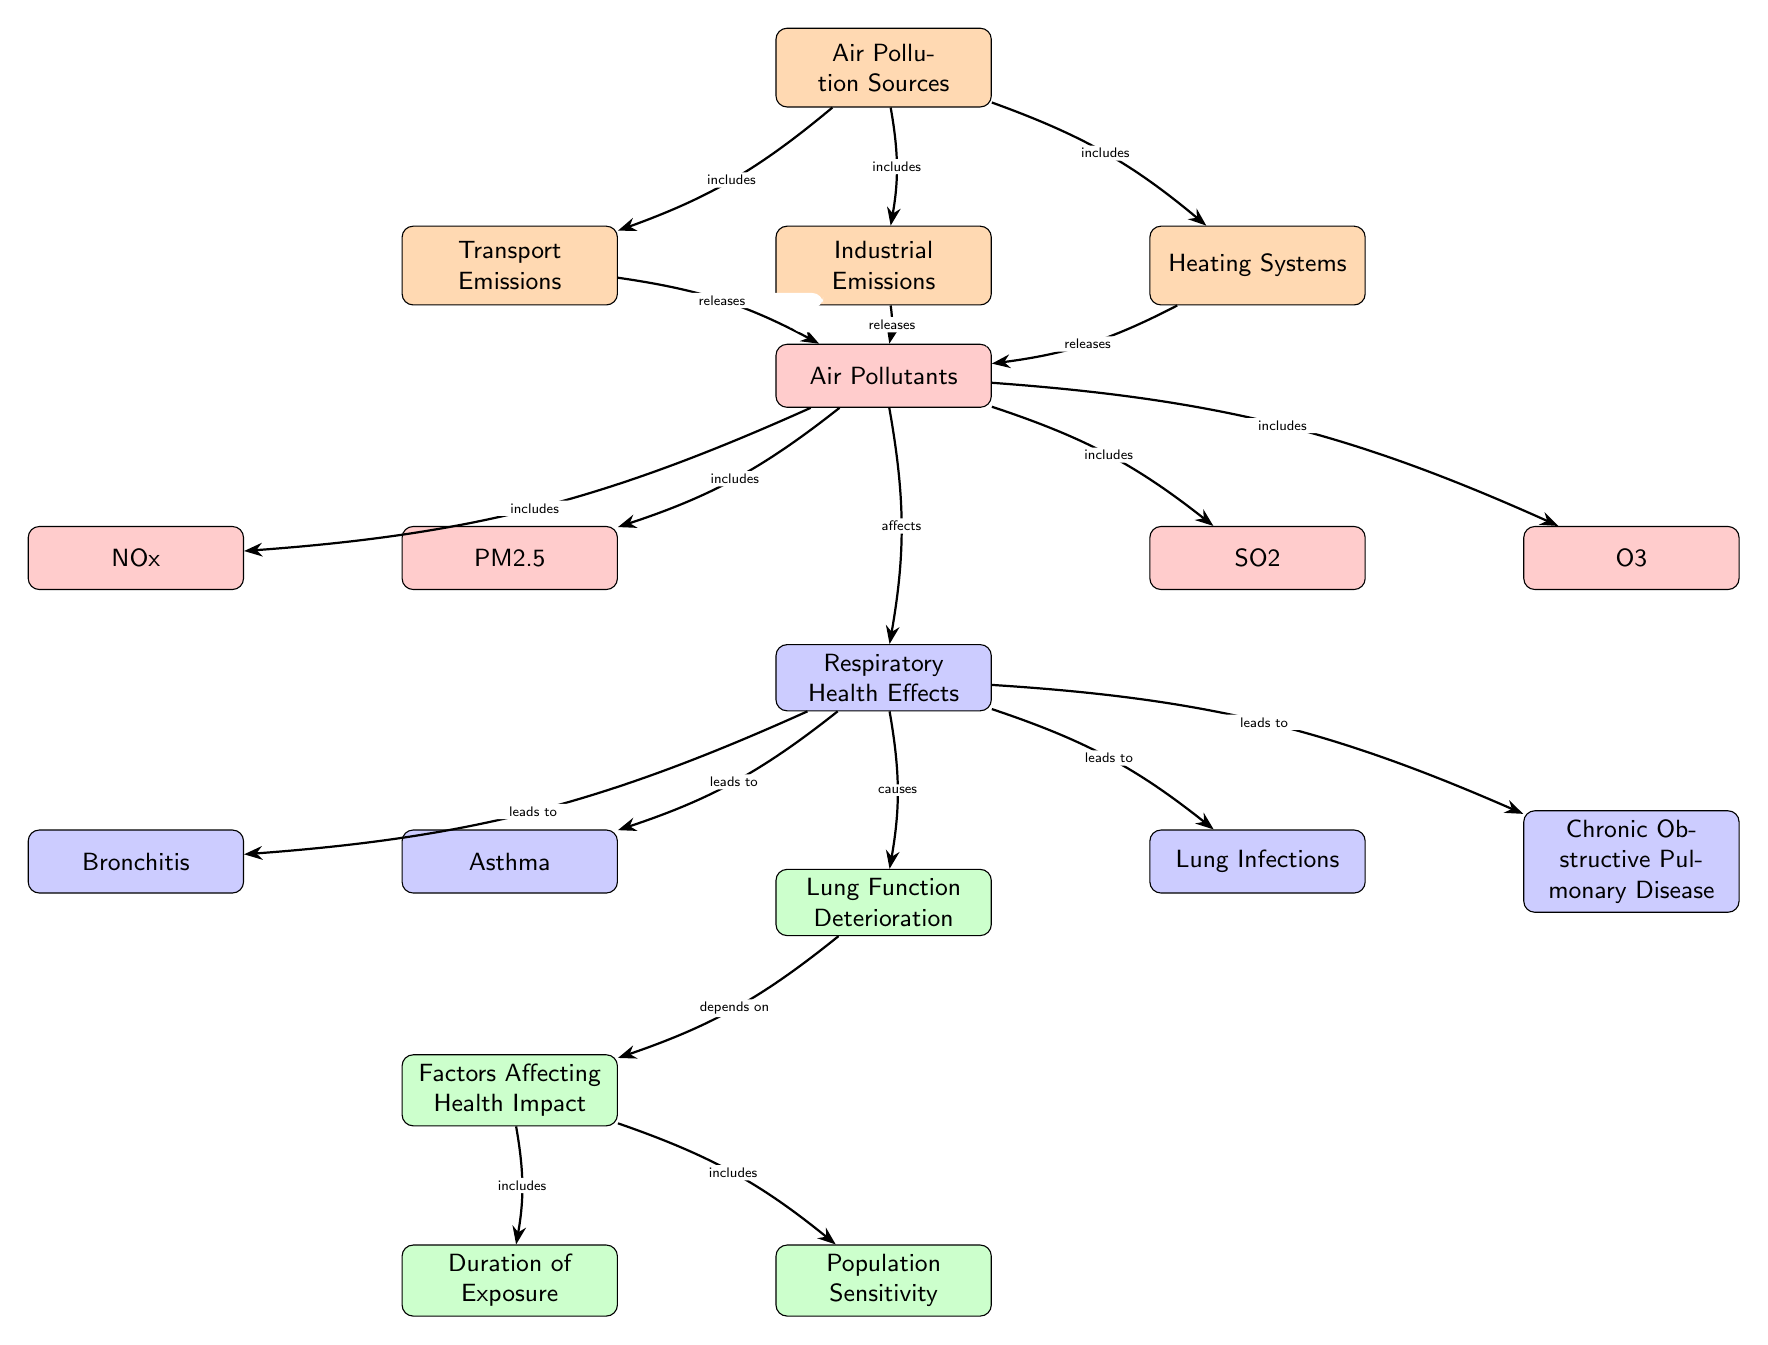What are the sources of air pollution? The diagram indicates three specific sources of air pollution: Transport Emissions, Industrial Emissions, and Heating Systems, which are all associated with the node labeled "Air Pollution Sources."
Answer: Transport Emissions, Industrial Emissions, Heating Systems How many air pollutants are listed? There are four distinct air pollutants shown in the diagram: PM2.5, NOx, SO2, and O3, all connected under the "Air Pollutants" node.
Answer: 4 What respiratory health effect is caused by air pollutants? The diagram shows that air pollutants affect respiratory health, leading to several conditions such as asthma, bronchitis, lung infections, and chronic obstructive pulmonary disease, all connected to the node labeled "Respiratory Health Effects."
Answer: Asthma, Bronchitis, Lung Infections, Chronic Obstructive Pulmonary Disease What factors affect lung function deterioration? The diagram identifies two factors under the node "Factors Affecting Health Impact" that are linked to lung function deterioration: Duration of Exposure and Population Sensitivity.
Answer: Duration of Exposure, Population Sensitivity Which air pollutant is derived from transport emissions? The diagram connects Transport Emissions directly to the node for Air Pollutants, which includes PM2.5, NOx, SO2, and O3. PM2.5 and NOx are examples of pollutants that can be derived from transport emissions based on common knowledge.
Answer: PM2.5, NOx How does the duration of exposure relate to lung function? The diagram indicates that Lung Function Deterioration is dependent on Factors Affecting Health Impact, specifically highlighting Duration of Exposure as one of those factors. Therefore, longer exposure times likely worsen lung function.
Answer: Depends on factors What is the relationship between air pollutants and respiratory health effects? The diagram shows that air pollutants directly affect respiratory health (indicated by the arrow from the "Air Pollutants" node to the "Respiratory Health Effects" node), leading to various health conditions.
Answer: Affects Which health condition is linked to lung function deterioration? The "Lung Function Deterioration" node in the diagram specifies that it is caused by respiratory health effects including conditions such as asthma, bronchitis, lung infections, and chronic obstructive pulmonary disease.
Answer: Asthma, Bronchitis, Lung Infections, Chronic Obstructive Pulmonary Disease 